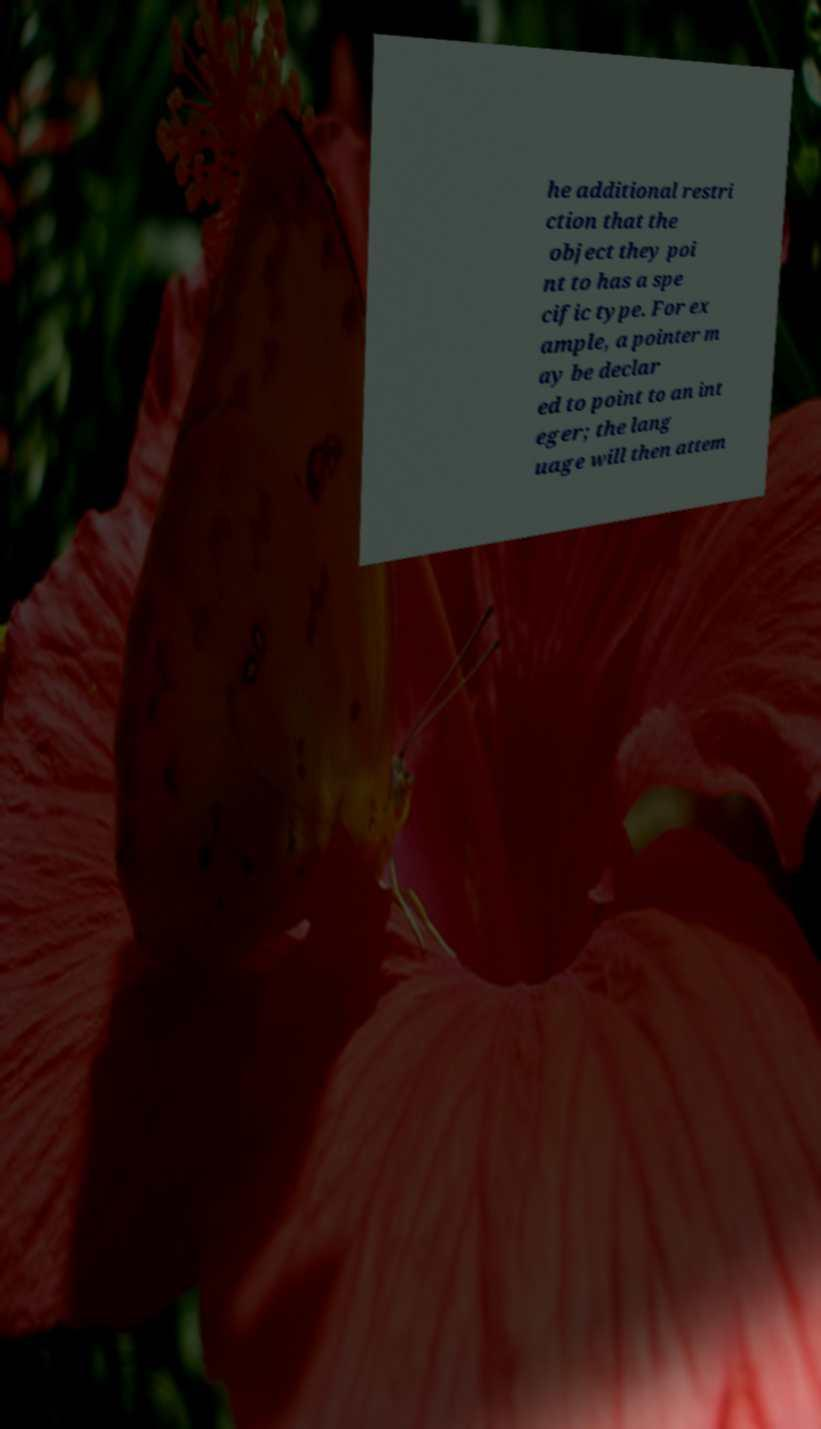Could you extract and type out the text from this image? he additional restri ction that the object they poi nt to has a spe cific type. For ex ample, a pointer m ay be declar ed to point to an int eger; the lang uage will then attem 